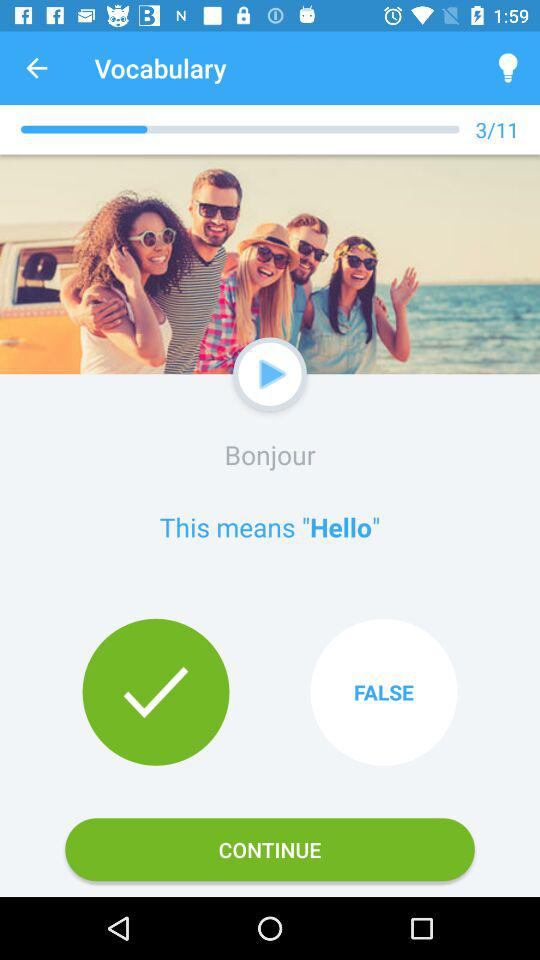How many questions are there in "Vocabulary"? There are 11 questions in "Vocabulary". 